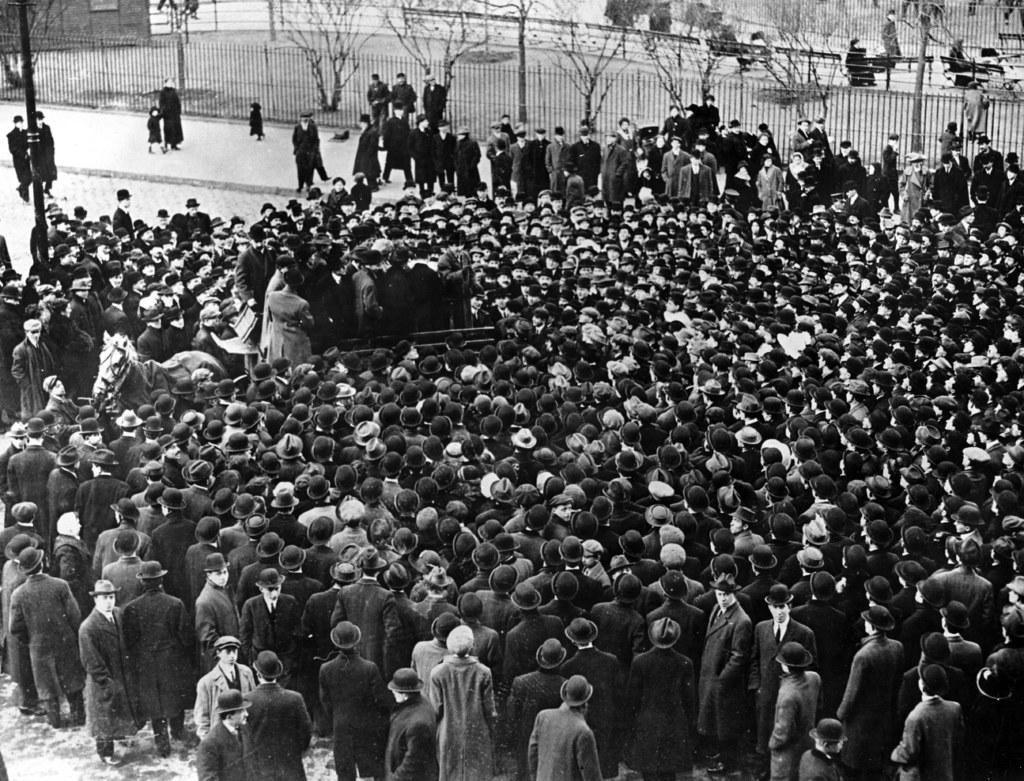What is the color scheme of the image? The image is black and white. What can be seen on the road in the image? There is a crowd standing on the road. What objects are present in the image that might be used for cooking? Grills are present in the image. What type of vegetation is visible in the image? Trees are visible in the image. What are some people doing in the image? There are persons sitting on chairs in the image. What language is being spoken by the crowd in the image? The image is black and white and does not provide any audio, so it is impossible to determine the language being spoken. Is there a doctor present in the image? There is no mention of a doctor or any medical professionals in the image. 